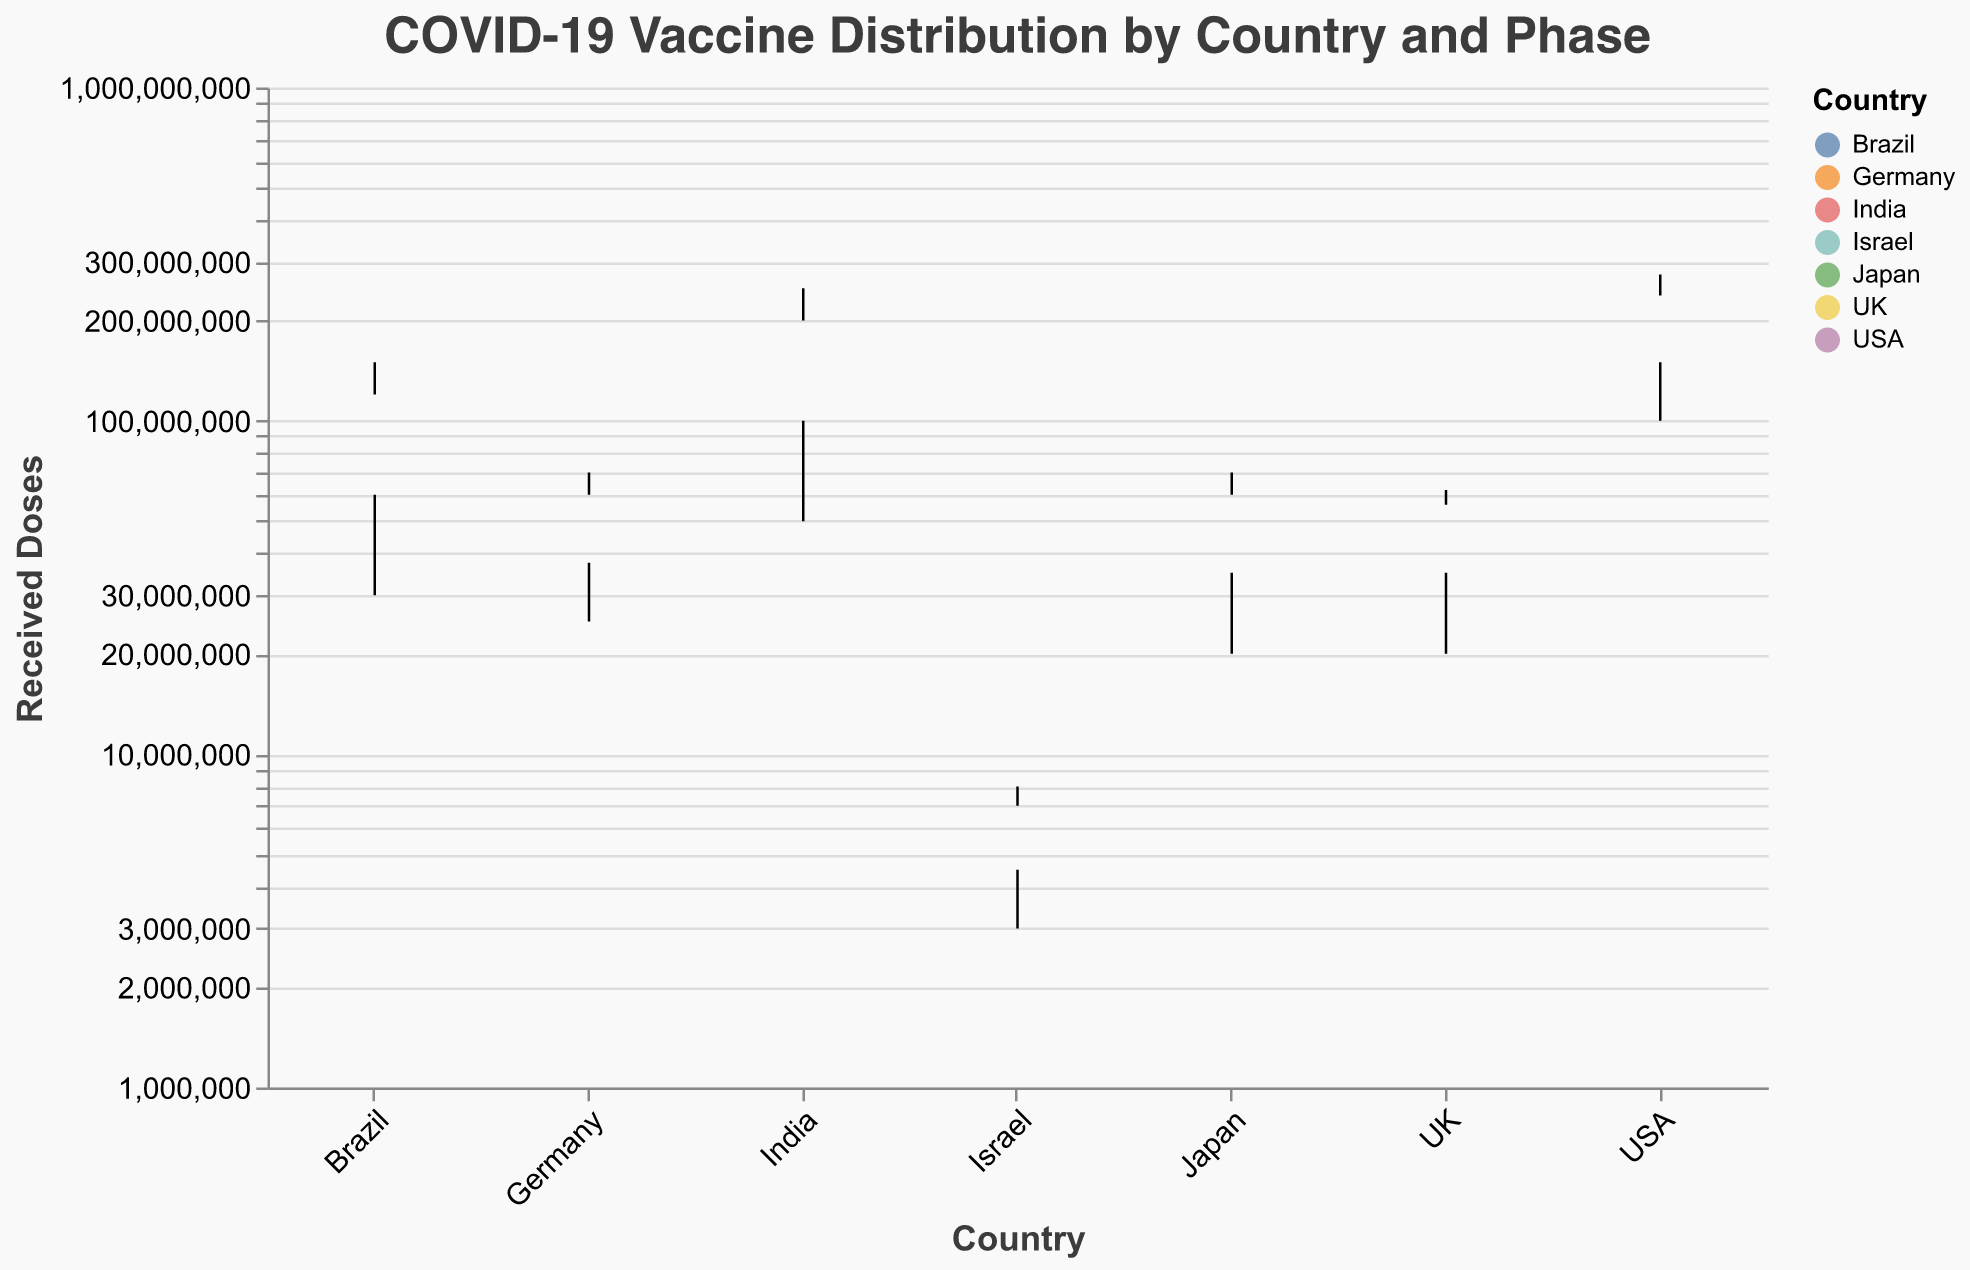What is the highest number of received doses for any country in Phase 3? By examining the figure, we look for the box plot whisker that extends the highest for Phase 3 across countries. The highest value is for the USA with 275 million doses.
Answer: 275 million Which phase in the UK received the fewest doses? To determine this, we observe the different colored box plots for the UK and identify the smallest value across phases. Phase 1 has the fewest doses with 20 million.
Answer: Phase 1 How many doses did Israel receive in total across all phases? Sum up the received doses across Phases 1, 2, and 3 for Israel: 3M (Phase 1) + 6M (Phase 2) + 8M (Phase 3) = 17M.
Answer: 17 million Which country had the smallest population size represented and how many doses did it receive in Phase 2? Israel has the smallest population, and in Phase 2 it received 6 million doses.
Answer: Israel, 6 million Between Germany and Brazil, which country had more variability in doses received across the phases? By comparing the range between the minimum and maximum doses for Germany and Brazil, Germany's doses varied from 25M to 70M, a 45M difference, whereas Brazil's doses varied from 30M to 150M, a 120M difference. Thus, Brazil had more variability.
Answer: Brazil On a log scale, which country's doses in Phase 3 appear closest to Japan’s doses in Phase 2? On the log scale, UK’s Phase 3 doses (62M) are closest to Japan’s Phase 2 doses (50M).
Answer: UK What would be the percentage increase in doses received from Phase 1 to Phase 3 for India? First, calculate the increase in doses: 250M in Phase 3 minus 50M in Phase 1 is 200M. Then, (200M / 50M) * 100% = 400% increase.
Answer: 400% Which country has the widest box plot representation for vaccination doses in Phase 3? Examining the width of the box plots, India has the widest representation in Phase 3, indicating high doses received.
Answer: India 